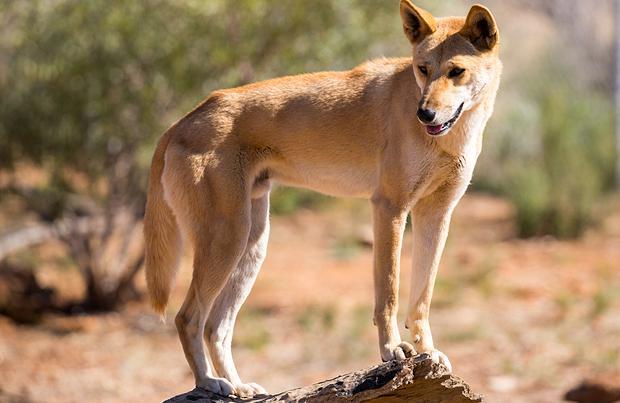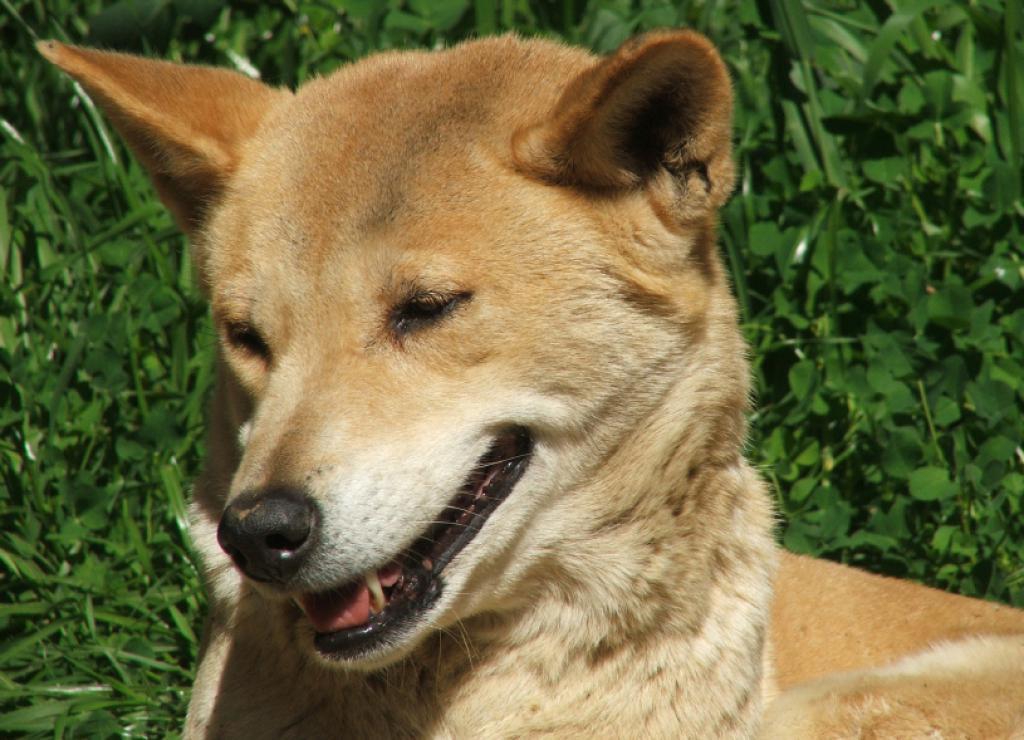The first image is the image on the left, the second image is the image on the right. For the images shown, is this caption "at lest one dog is showing its teeth" true? Answer yes or no. Yes. 